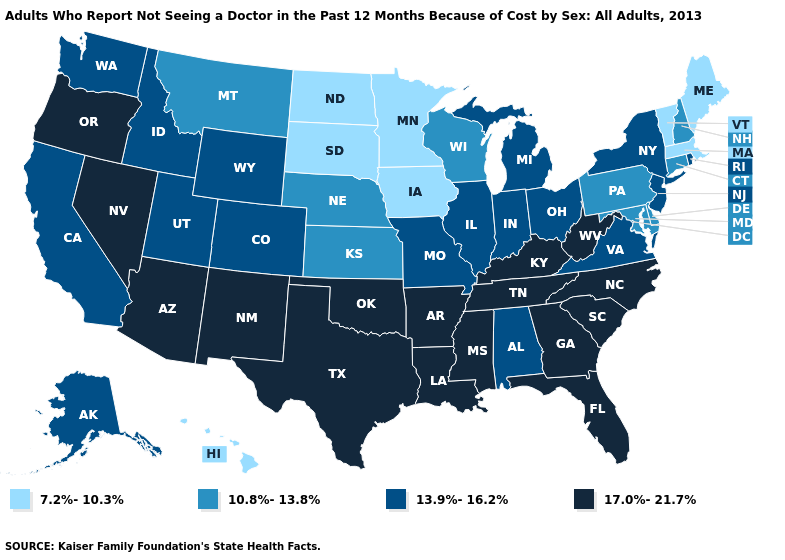Does Iowa have the lowest value in the USA?
Keep it brief. Yes. Does Colorado have the highest value in the West?
Write a very short answer. No. What is the highest value in states that border Kansas?
Concise answer only. 17.0%-21.7%. Does Michigan have a lower value than North Carolina?
Answer briefly. Yes. Among the states that border Michigan , does Wisconsin have the highest value?
Short answer required. No. Is the legend a continuous bar?
Answer briefly. No. Among the states that border Washington , which have the highest value?
Be succinct. Oregon. Which states have the highest value in the USA?
Answer briefly. Arizona, Arkansas, Florida, Georgia, Kentucky, Louisiana, Mississippi, Nevada, New Mexico, North Carolina, Oklahoma, Oregon, South Carolina, Tennessee, Texas, West Virginia. Does South Dakota have the lowest value in the USA?
Quick response, please. Yes. Among the states that border Tennessee , which have the highest value?
Write a very short answer. Arkansas, Georgia, Kentucky, Mississippi, North Carolina. What is the value of Mississippi?
Write a very short answer. 17.0%-21.7%. Does Hawaii have a lower value than Michigan?
Give a very brief answer. Yes. Does Oregon have the highest value in the West?
Give a very brief answer. Yes. What is the lowest value in states that border Virginia?
Answer briefly. 10.8%-13.8%. How many symbols are there in the legend?
Be succinct. 4. 